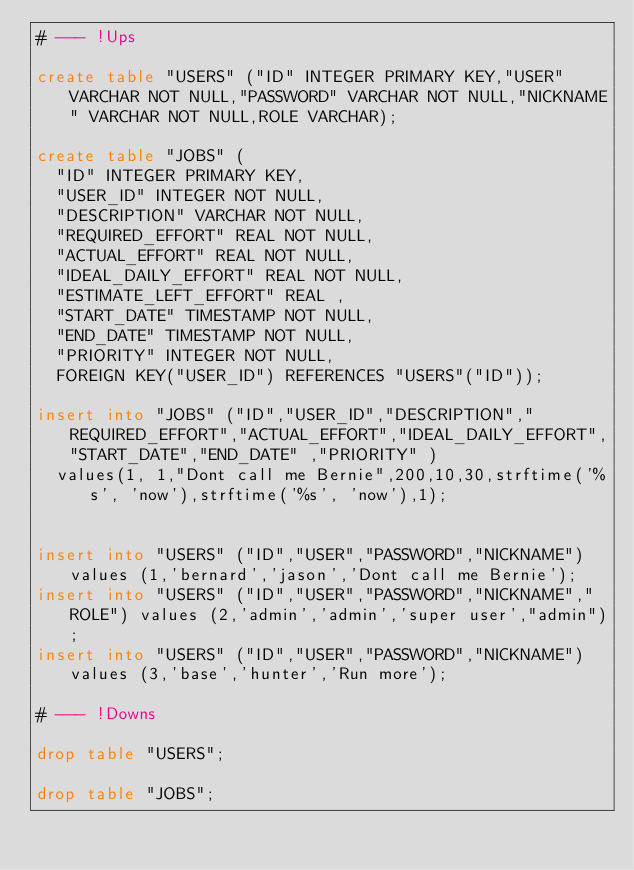Convert code to text. <code><loc_0><loc_0><loc_500><loc_500><_SQL_># --- !Ups

create table "USERS" ("ID" INTEGER PRIMARY KEY,"USER" VARCHAR NOT NULL,"PASSWORD" VARCHAR NOT NULL,"NICKNAME" VARCHAR NOT NULL,ROLE VARCHAR);

create table "JOBS" (
	"ID" INTEGER PRIMARY KEY,
	"USER_ID" INTEGER NOT NULL,
	"DESCRIPTION" VARCHAR NOT NULL, 
	"REQUIRED_EFFORT" REAL NOT NULL, 
	"ACTUAL_EFFORT" REAL NOT NULL, 
	"IDEAL_DAILY_EFFORT" REAL NOT NULL, 
	"ESTIMATE_LEFT_EFFORT" REAL , 
	"START_DATE" TIMESTAMP NOT NULL,
	"END_DATE" TIMESTAMP NOT NULL,
	"PRIORITY" INTEGER NOT NULL,
	FOREIGN KEY("USER_ID") REFERENCES "USERS"("ID"));

insert into "JOBS" ("ID","USER_ID","DESCRIPTION","REQUIRED_EFFORT","ACTUAL_EFFORT","IDEAL_DAILY_EFFORT","START_DATE","END_DATE" ,"PRIORITY" )
	values(1, 1,"Dont call me Bernie",200,10,30,strftime('%s', 'now'),strftime('%s', 'now'),1);


insert into "USERS" ("ID","USER","PASSWORD","NICKNAME") values (1,'bernard','jason','Dont call me Bernie');	
insert into "USERS" ("ID","USER","PASSWORD","NICKNAME","ROLE") values (2,'admin','admin','super user',"admin");
insert into "USERS" ("ID","USER","PASSWORD","NICKNAME") values (3,'base','hunter','Run more');	

# --- !Downs

drop table "USERS";

drop table "JOBS";
</code> 